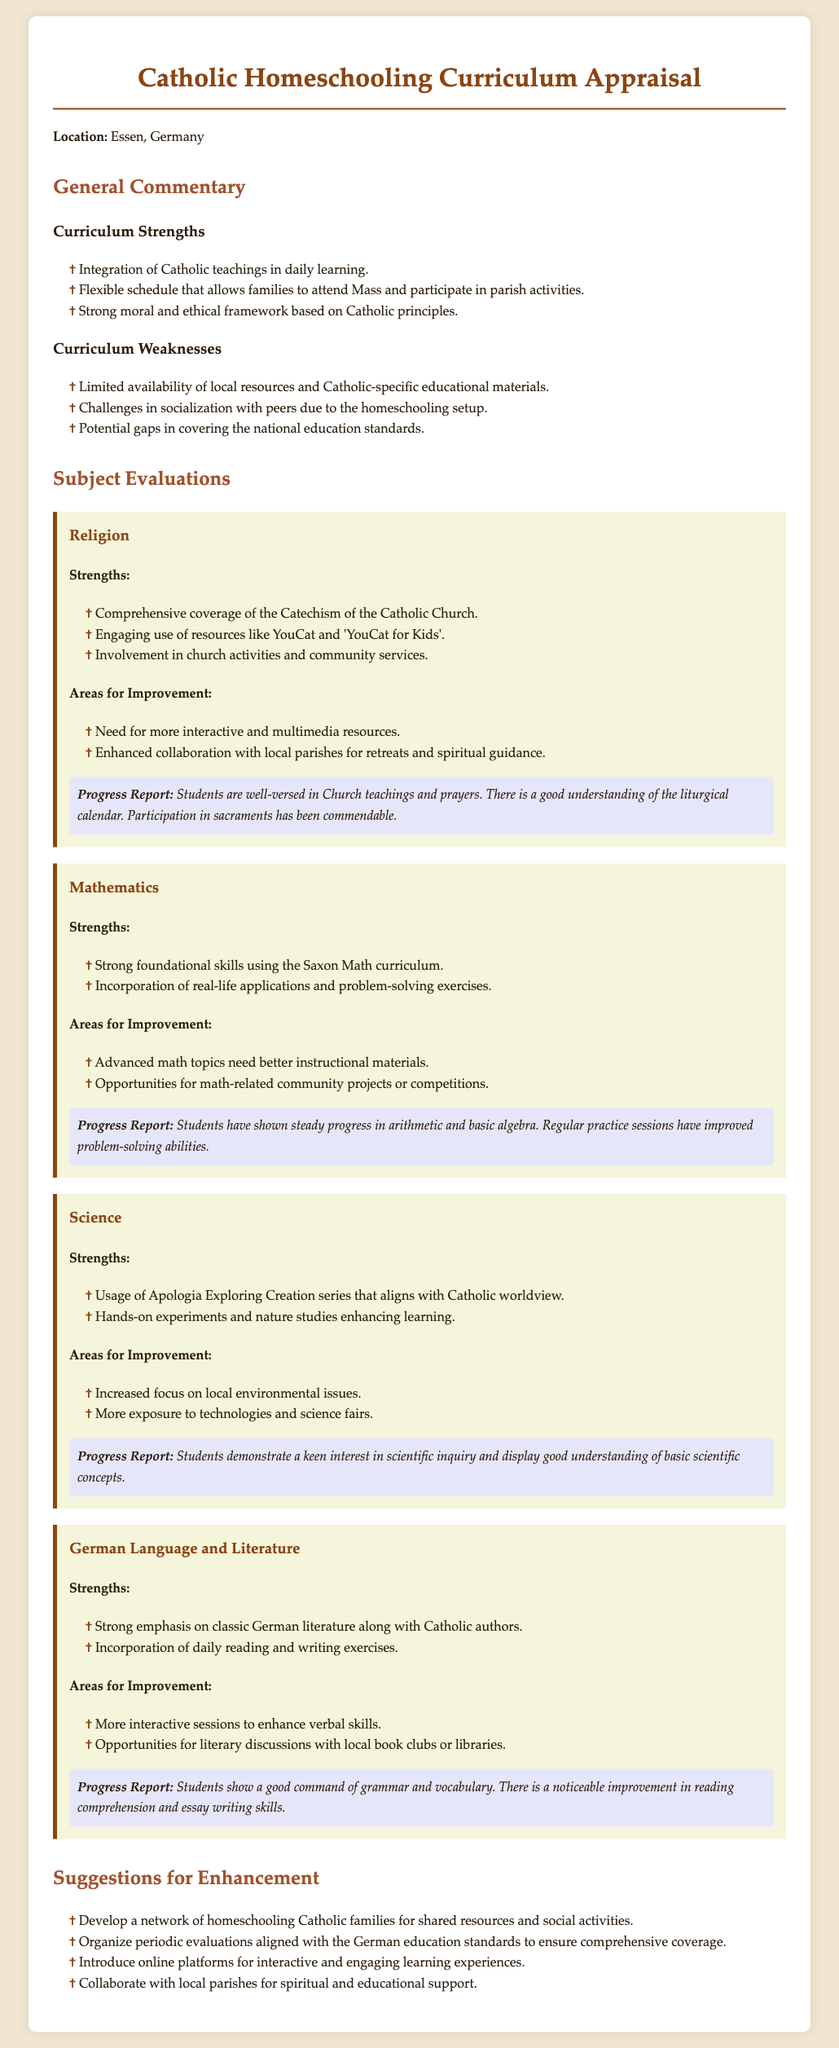what is the location of the appraisal? The location is specified in the document as Essen, Germany.
Answer: Essen, Germany what are the strengths listed for the Religion subject? The strengths include comprehensive coverage of the Catechism, engaging resources, and involvement in church activities.
Answer: Comprehensive coverage of the Catechism of the Catholic Church, Engaging use of resources like YouCat and 'YouCat for Kids', Involvement in church activities and community services what is one weakness of the curriculum mentioned? One weakness noted is the limited availability of local resources and Catholic-specific educational materials.
Answer: Limited availability of local resources and Catholic-specific educational materials how many strengths are listed for Mathematics? The document lists two strengths for Mathematics.
Answer: Two what is one suggestion for enhancement? One suggestion includes developing a network of homeschooling Catholic families for shared resources and social activities.
Answer: Develop a network of homeschooling Catholic families for shared resources and social activities what is the progress report for Science? The progress report states students demonstrate a keen interest in scientific inquiry and a good understanding of scientific concepts.
Answer: Students demonstrate a keen interest in scientific inquiry and display good understanding of basic scientific concepts how many subjects are evaluated in the document? The document evaluates four subjects: Religion, Mathematics, Science, and German Language and Literature.
Answer: Four what is highlighted as an area for improvement in German Language and Literature? The document highlights the need for more interactive sessions to enhance verbal skills as an area for improvement.
Answer: More interactive sessions to enhance verbal skills 